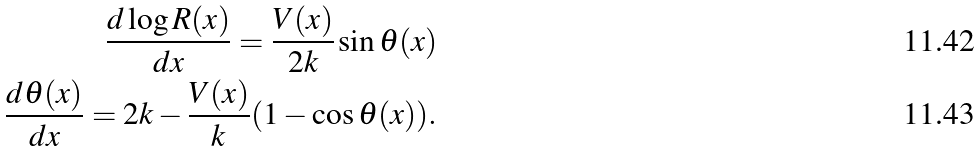<formula> <loc_0><loc_0><loc_500><loc_500>\frac { d \log R ( x ) } { d x } = \frac { V ( x ) } { 2 k } \sin \theta ( x ) \\ \frac { d \theta ( x ) } { d x } = 2 k - \frac { V ( x ) } { k } ( 1 - \cos \theta ( x ) ) .</formula> 